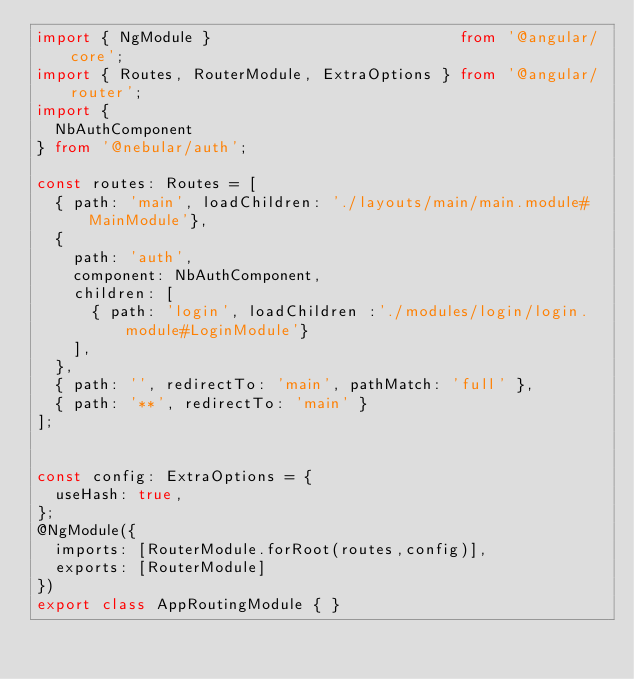Convert code to text. <code><loc_0><loc_0><loc_500><loc_500><_TypeScript_>import { NgModule }                           from '@angular/core';
import { Routes, RouterModule, ExtraOptions } from '@angular/router';
import {
  NbAuthComponent
} from '@nebular/auth';

const routes: Routes = [
  { path: 'main', loadChildren: './layouts/main/main.module#MainModule'},
  {
    path: 'auth',
    component: NbAuthComponent,
    children: [
      { path: 'login', loadChildren :'./modules/login/login.module#LoginModule'}
    ],
  },
  { path: '', redirectTo: 'main', pathMatch: 'full' },
  { path: '**', redirectTo: 'main' }
];


const config: ExtraOptions = {
  useHash: true,
};
@NgModule({
  imports: [RouterModule.forRoot(routes,config)],
  exports: [RouterModule]
})
export class AppRoutingModule { }
</code> 